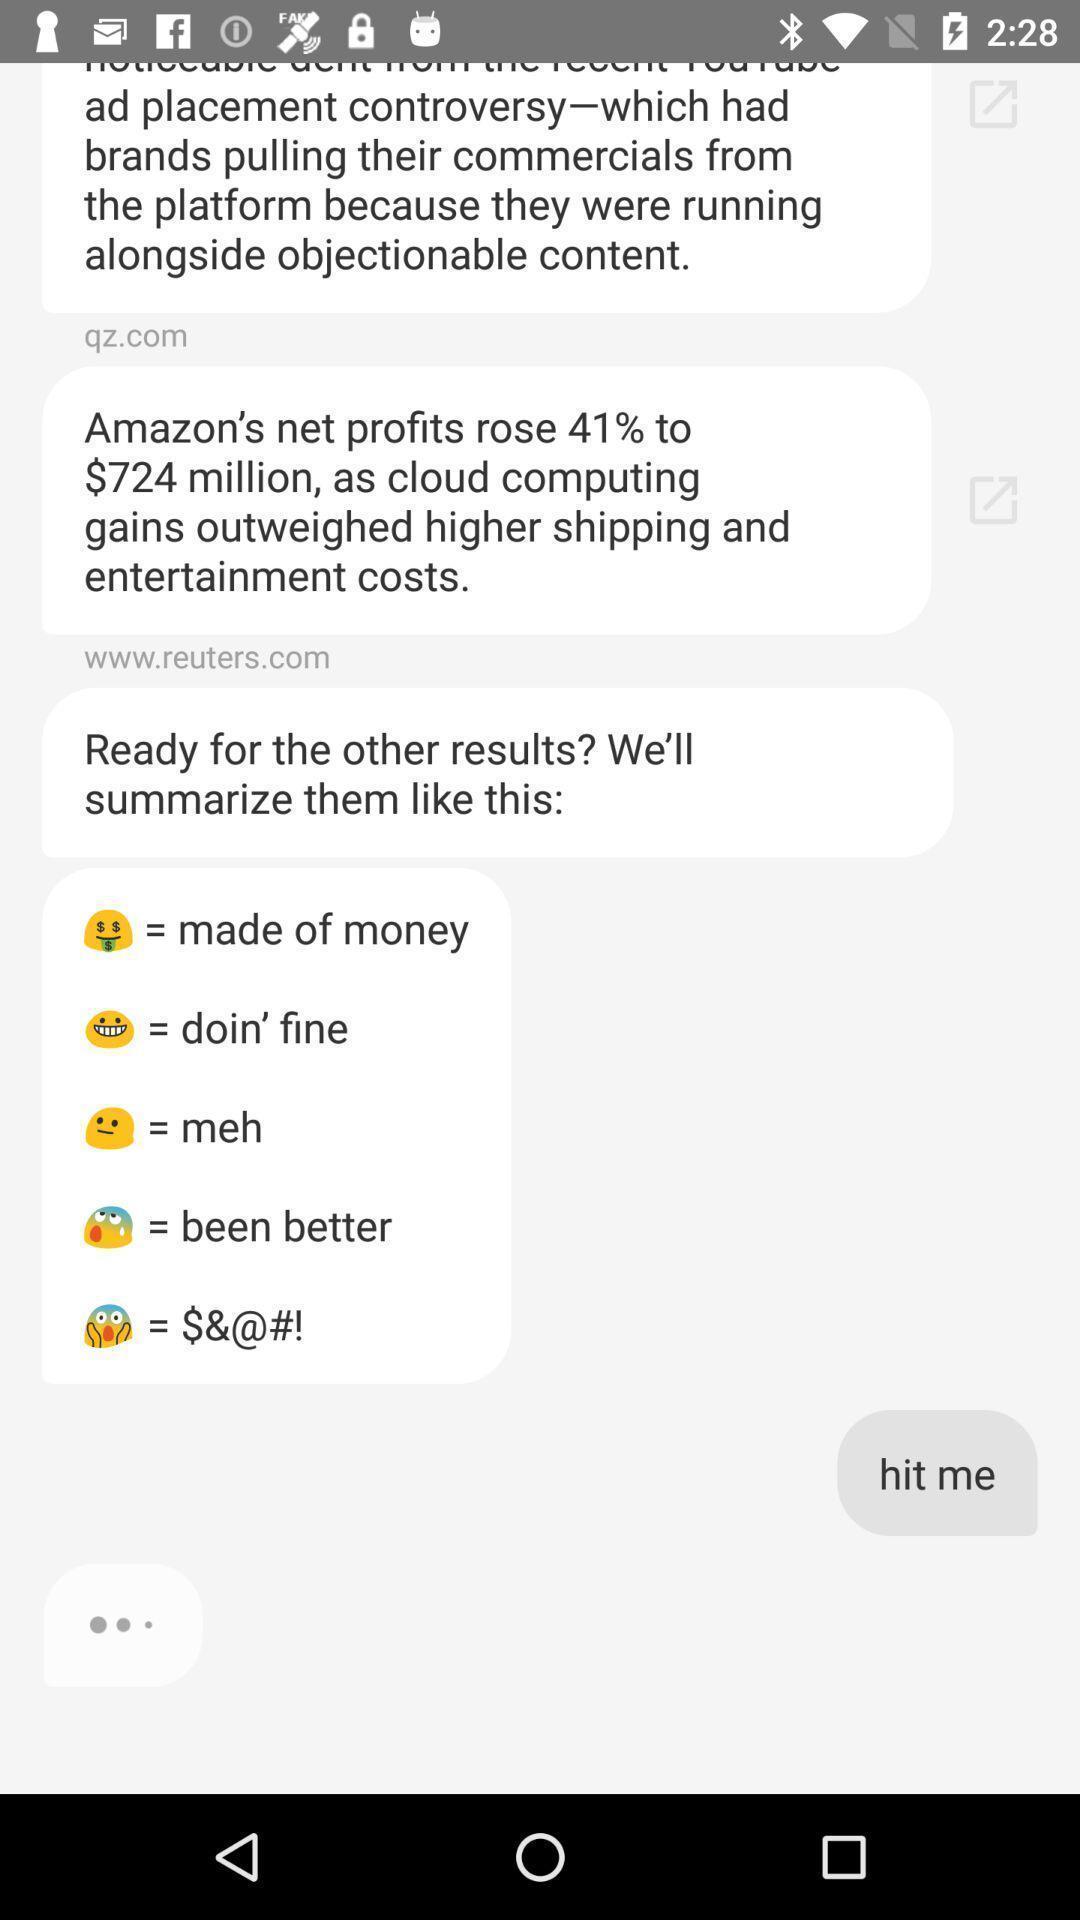Give me a narrative description of this picture. Page showing chatting messages in the chatting app. 